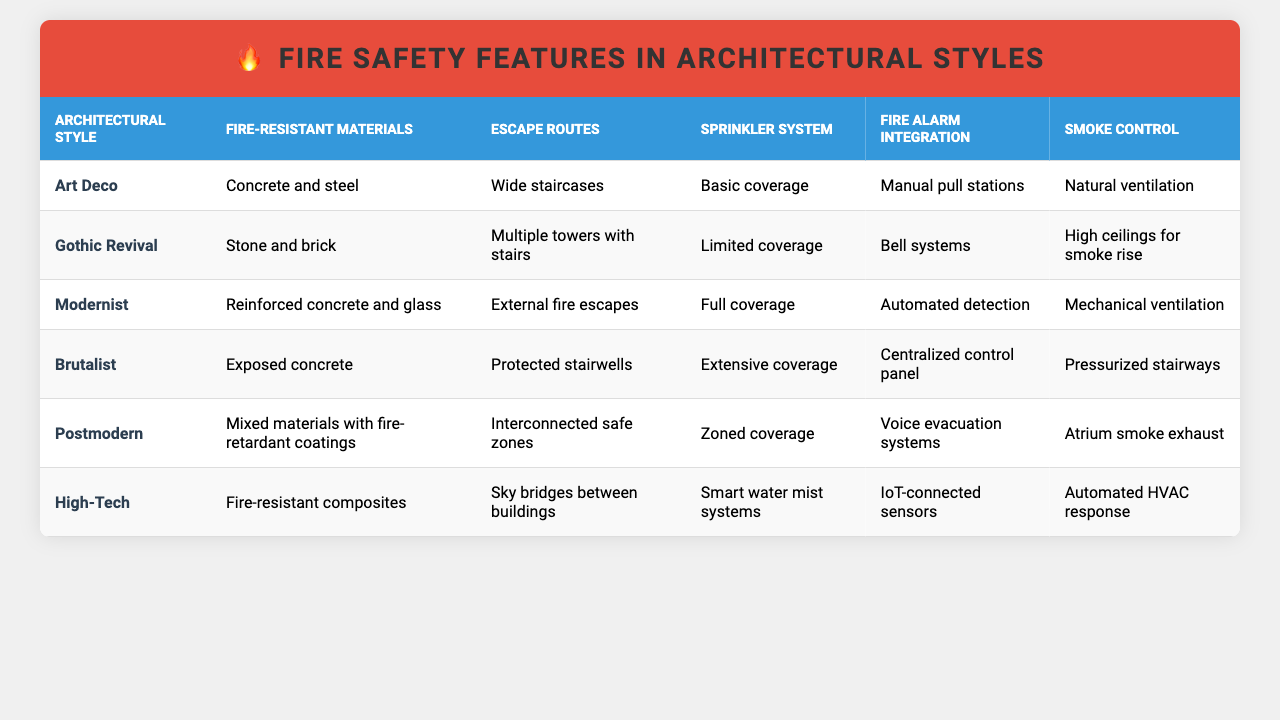What fire-resistant materials are used in the Modernist architectural style? The table indicates that the Modernist style uses reinforced concrete and glass as fire-resistant materials.
Answer: Reinforced concrete and glass Which architectural style has the most extensive sprinkler system coverage? Reviewing the table, the Brutalist style is noted for having extensive coverage of the sprinkler system, while other styles have either basic, limited, or zoned coverage.
Answer: Brutalist Is there a sprinkler system in the Gothic Revival architectural style? The table shows that the Gothic Revival style has limited coverage of the sprinkler system, indicating that some level of sprinkler system is present.
Answer: Yes What is the common smoke control system used in Brutalist architecture? According to the table, Brutalist architecture employs pressurized stairways for smoke control.
Answer: Pressurized stairways Which two architectural styles have automated fire alarm integration? A comparison of the table reveals that Modernist and Postmodern styles both utilize automated detection and voice evacuation systems, respectively.
Answer: Modernist and Postmodern How does the escape route differ between the Art Deco and High-Tech styles? The table illustrates that Art Deco features wide staircases for escape routes, while High-Tech has sky bridges between buildings, indicating a significant difference in design for escape routes.
Answer: Wide staircases vs. sky bridges In terms of fire safety features, which architectural style utilizes natural ventilation for smoke control? The data identifies that the Art Deco style incorporates natural ventilation as its smoke control method.
Answer: Art Deco What type of materials are commonly used in Postmodern architecture for fire resistance? The table specifies that Postmodern architecture employs mixed materials with fire-retardant coatings.
Answer: Mixed materials with fire-retardant coatings Which architectural style includes automated HVAC responses for smoke control? According to the table, the High-Tech architectural style has automated HVAC response as its smoke control mechanism.
Answer: High-Tech If a building has basic sprinkler coverage, which architectural style is it likely to represent? The table shows that the Art Deco style is characterized by basic coverage of the sprinkler system, suggesting that a building with this feature may be in this style.
Answer: Art Deco 